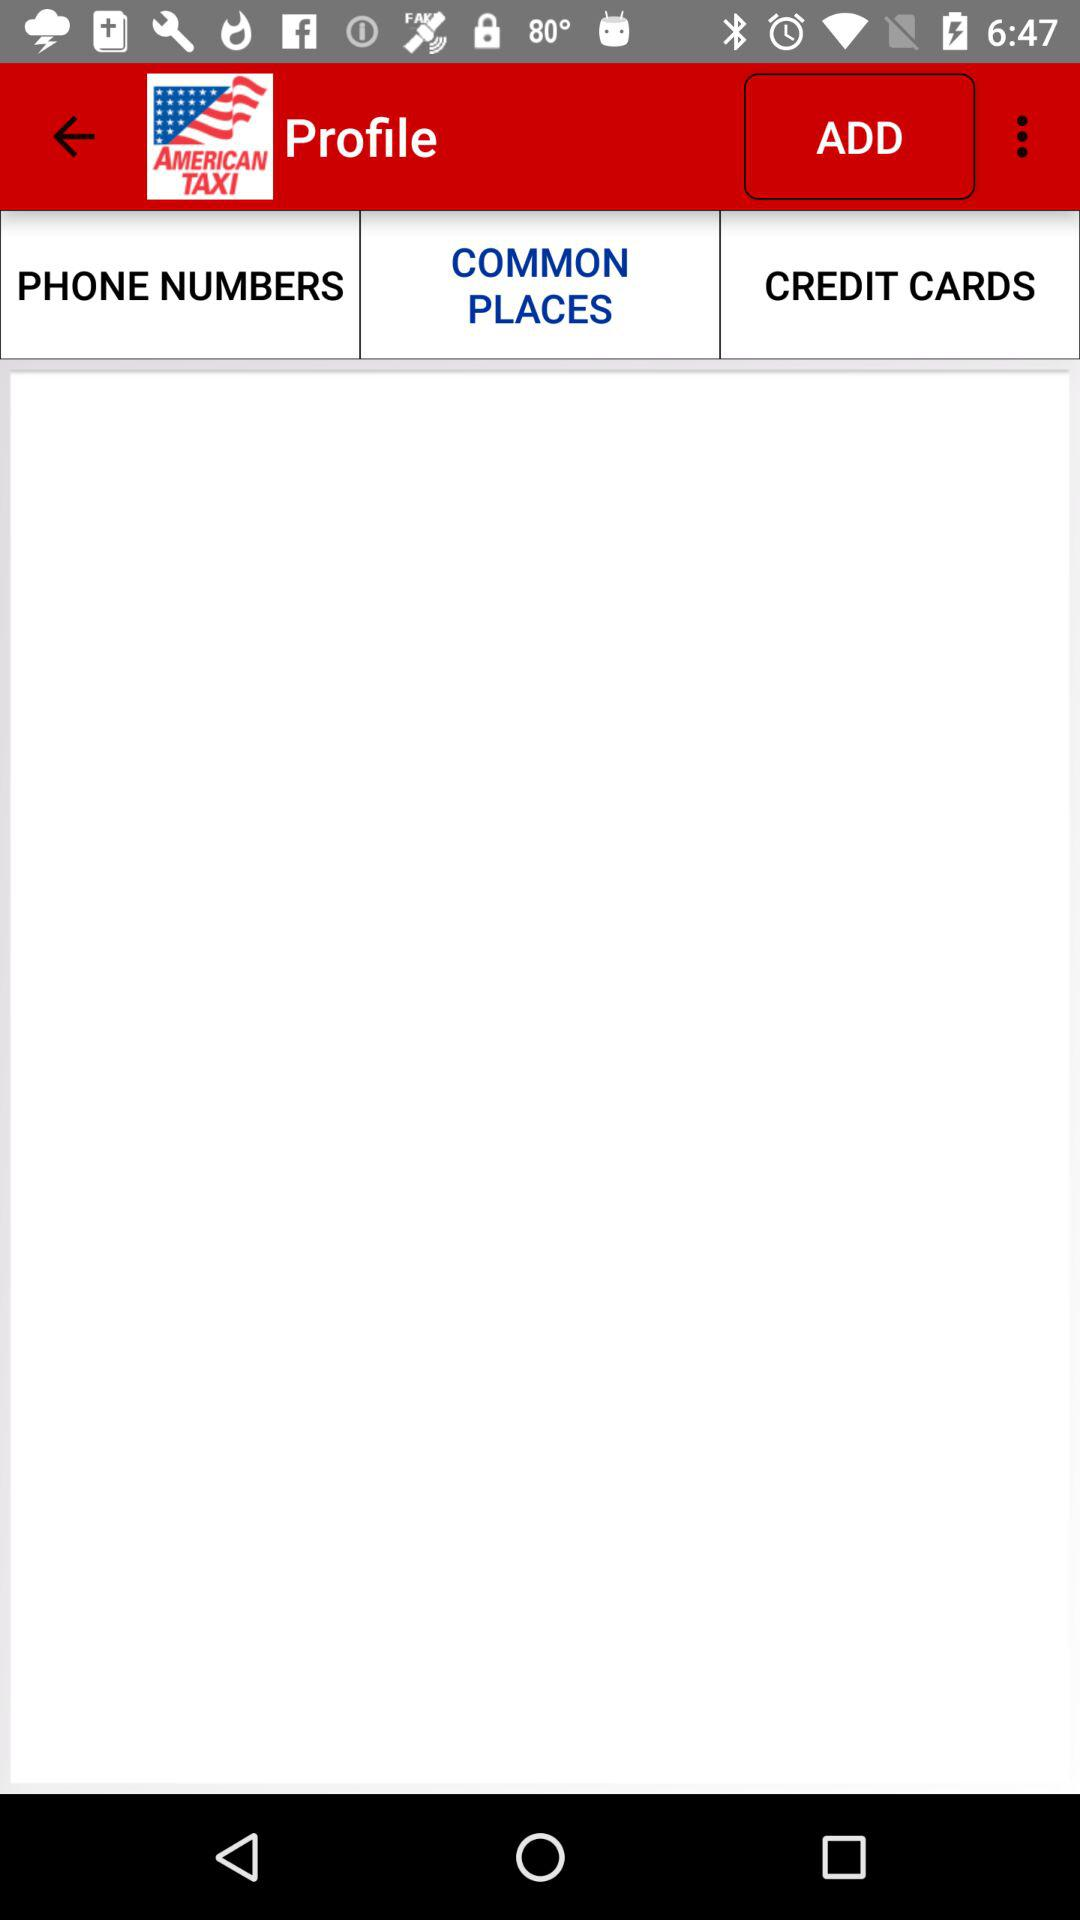What is the application name? The application name is "American Taxi Dispatch". 